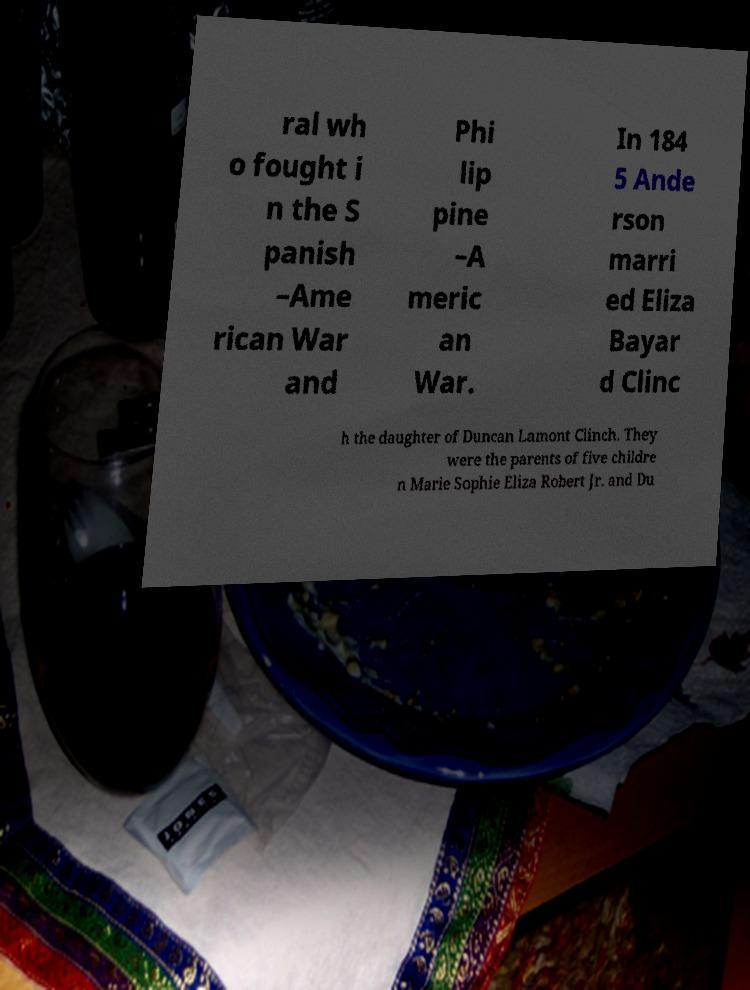Can you read and provide the text displayed in the image?This photo seems to have some interesting text. Can you extract and type it out for me? ral wh o fought i n the S panish –Ame rican War and Phi lip pine –A meric an War. In 184 5 Ande rson marri ed Eliza Bayar d Clinc h the daughter of Duncan Lamont Clinch. They were the parents of five childre n Marie Sophie Eliza Robert Jr. and Du 